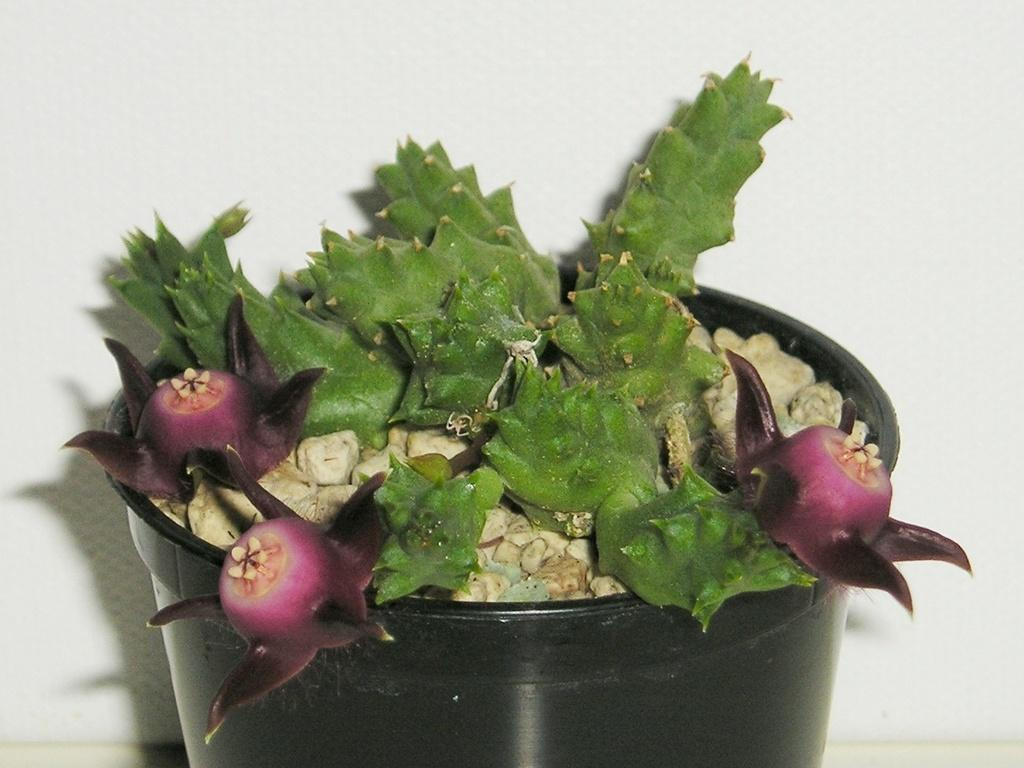What is present in the image? There is a plant in the image. Can you describe the container in which the plant is placed? The plant is placed in a black color flower pot. What type of ornament can be seen on the donkey in the image? There is no donkey or ornament present in the image; it only features a plant in a black flower pot. 